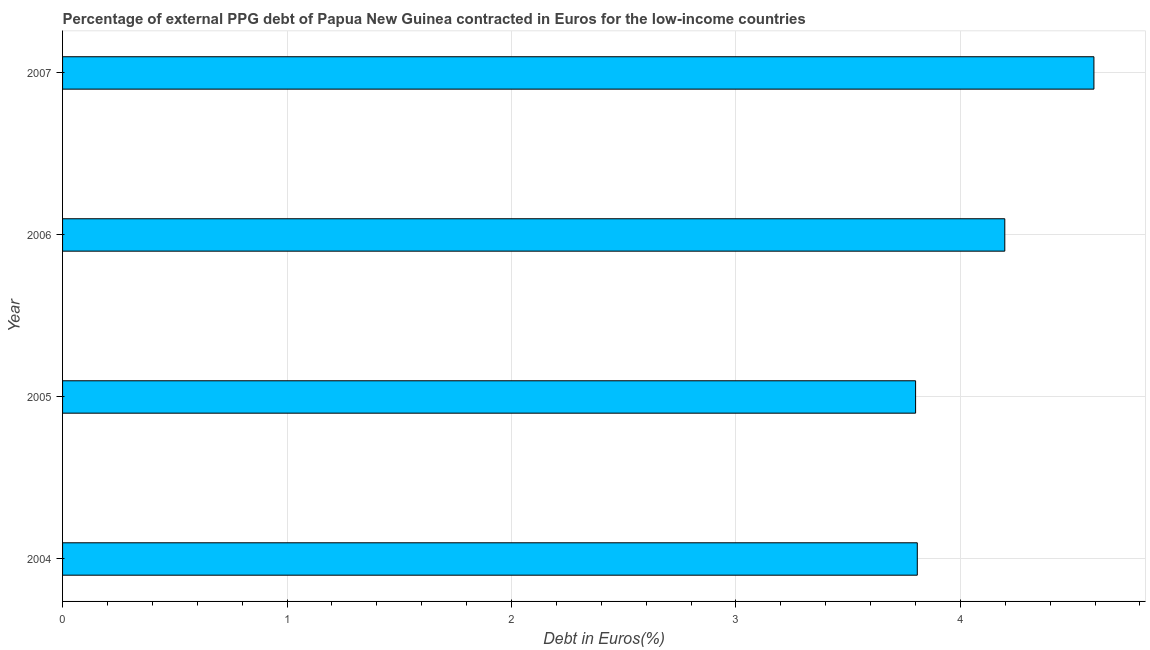Does the graph contain any zero values?
Provide a short and direct response. No. Does the graph contain grids?
Offer a very short reply. Yes. What is the title of the graph?
Keep it short and to the point. Percentage of external PPG debt of Papua New Guinea contracted in Euros for the low-income countries. What is the label or title of the X-axis?
Make the answer very short. Debt in Euros(%). What is the currency composition of ppg debt in 2004?
Provide a succinct answer. 3.81. Across all years, what is the maximum currency composition of ppg debt?
Ensure brevity in your answer.  4.59. Across all years, what is the minimum currency composition of ppg debt?
Keep it short and to the point. 3.8. In which year was the currency composition of ppg debt maximum?
Provide a succinct answer. 2007. What is the sum of the currency composition of ppg debt?
Provide a short and direct response. 16.4. What is the difference between the currency composition of ppg debt in 2005 and 2007?
Your answer should be compact. -0.8. What is the average currency composition of ppg debt per year?
Keep it short and to the point. 4.1. What is the median currency composition of ppg debt?
Your answer should be very brief. 4. In how many years, is the currency composition of ppg debt greater than 3.8 %?
Give a very brief answer. 4. Do a majority of the years between 2006 and 2004 (inclusive) have currency composition of ppg debt greater than 1.2 %?
Your answer should be compact. Yes. What is the ratio of the currency composition of ppg debt in 2005 to that in 2007?
Your answer should be compact. 0.83. Is the currency composition of ppg debt in 2004 less than that in 2005?
Your response must be concise. No. What is the difference between the highest and the second highest currency composition of ppg debt?
Provide a succinct answer. 0.4. What is the difference between the highest and the lowest currency composition of ppg debt?
Ensure brevity in your answer.  0.79. In how many years, is the currency composition of ppg debt greater than the average currency composition of ppg debt taken over all years?
Keep it short and to the point. 2. How many bars are there?
Keep it short and to the point. 4. Are all the bars in the graph horizontal?
Make the answer very short. Yes. How many years are there in the graph?
Give a very brief answer. 4. What is the difference between two consecutive major ticks on the X-axis?
Offer a very short reply. 1. What is the Debt in Euros(%) of 2004?
Offer a terse response. 3.81. What is the Debt in Euros(%) in 2005?
Your answer should be compact. 3.8. What is the Debt in Euros(%) of 2006?
Make the answer very short. 4.2. What is the Debt in Euros(%) of 2007?
Offer a very short reply. 4.59. What is the difference between the Debt in Euros(%) in 2004 and 2005?
Ensure brevity in your answer.  0.01. What is the difference between the Debt in Euros(%) in 2004 and 2006?
Ensure brevity in your answer.  -0.39. What is the difference between the Debt in Euros(%) in 2004 and 2007?
Your answer should be very brief. -0.79. What is the difference between the Debt in Euros(%) in 2005 and 2006?
Your answer should be compact. -0.4. What is the difference between the Debt in Euros(%) in 2005 and 2007?
Your answer should be compact. -0.79. What is the difference between the Debt in Euros(%) in 2006 and 2007?
Your answer should be very brief. -0.4. What is the ratio of the Debt in Euros(%) in 2004 to that in 2005?
Give a very brief answer. 1. What is the ratio of the Debt in Euros(%) in 2004 to that in 2006?
Keep it short and to the point. 0.91. What is the ratio of the Debt in Euros(%) in 2004 to that in 2007?
Keep it short and to the point. 0.83. What is the ratio of the Debt in Euros(%) in 2005 to that in 2006?
Your response must be concise. 0.91. What is the ratio of the Debt in Euros(%) in 2005 to that in 2007?
Your answer should be very brief. 0.83. What is the ratio of the Debt in Euros(%) in 2006 to that in 2007?
Make the answer very short. 0.91. 